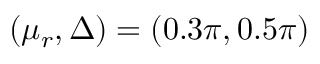<formula> <loc_0><loc_0><loc_500><loc_500>( \mu _ { r } , \Delta ) = ( 0 . 3 \pi , 0 . 5 \pi )</formula> 